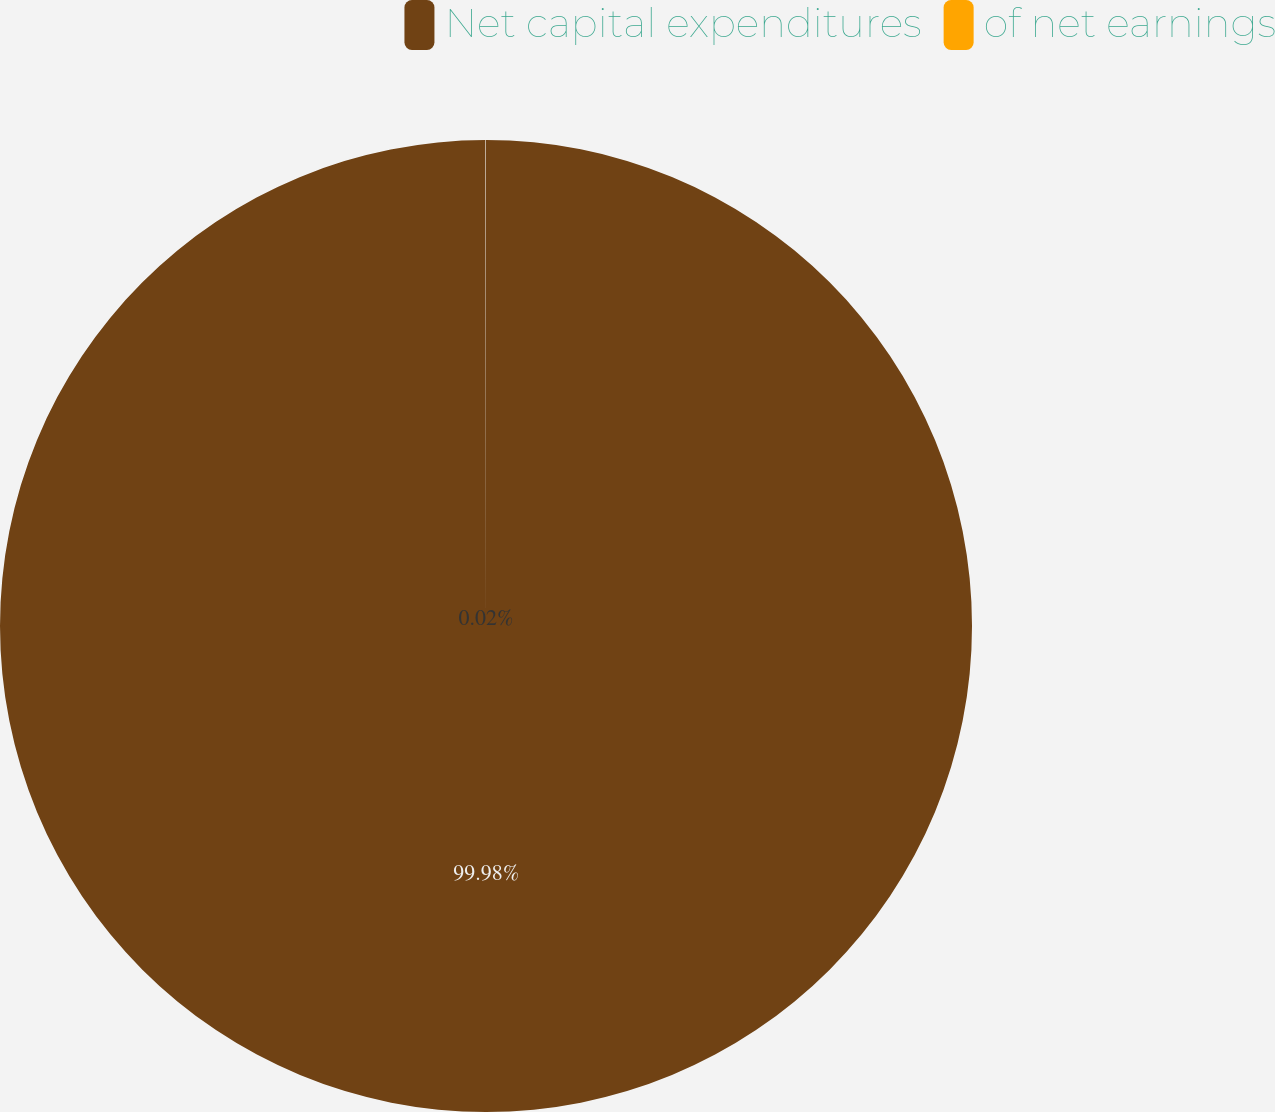Convert chart. <chart><loc_0><loc_0><loc_500><loc_500><pie_chart><fcel>Net capital expenditures<fcel>of net earnings<nl><fcel>99.98%<fcel>0.02%<nl></chart> 